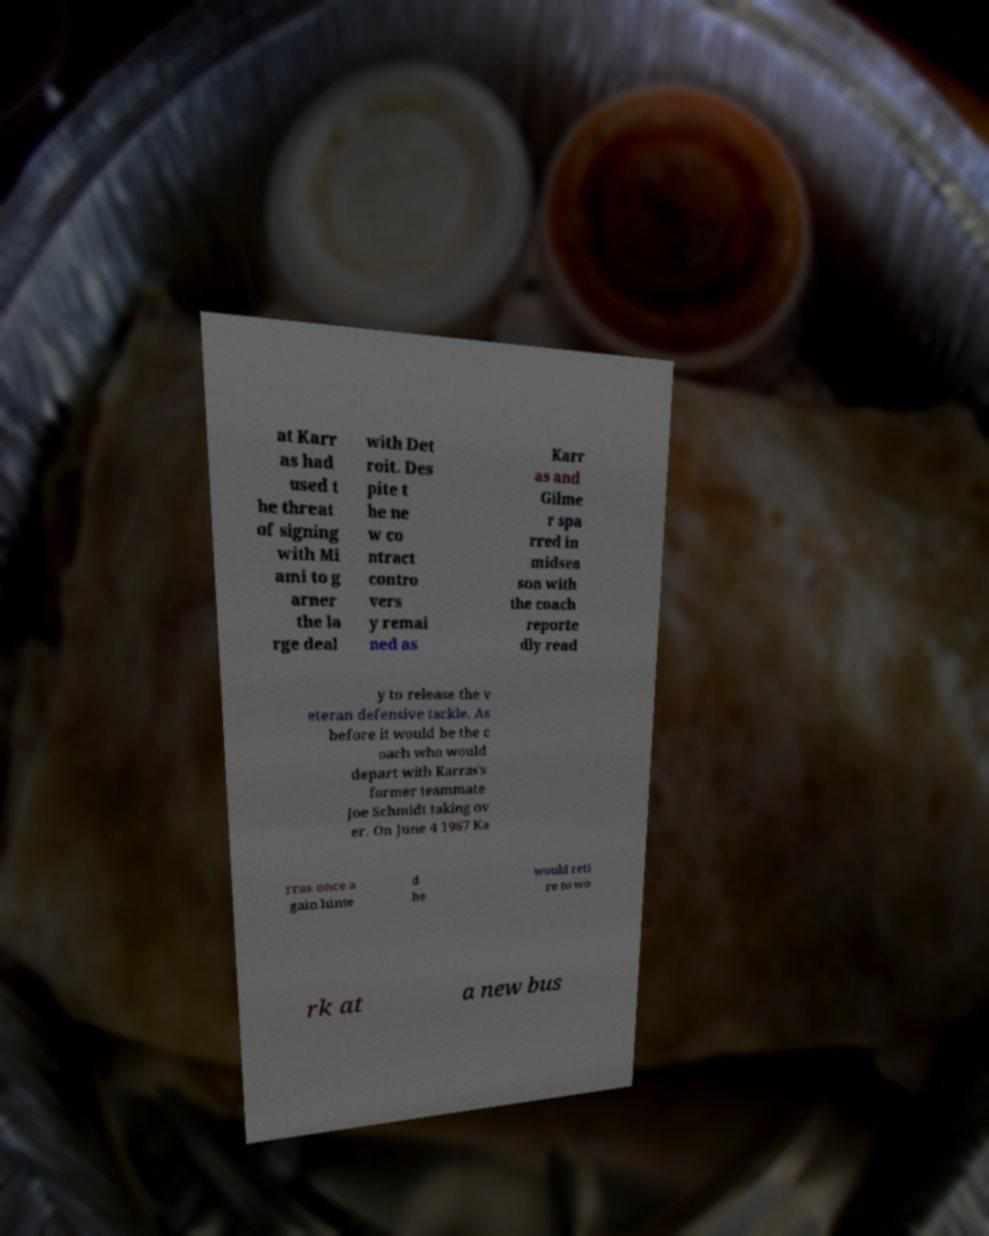There's text embedded in this image that I need extracted. Can you transcribe it verbatim? at Karr as had used t he threat of signing with Mi ami to g arner the la rge deal with Det roit. Des pite t he ne w co ntract contro vers y remai ned as Karr as and Gilme r spa rred in midsea son with the coach reporte dly read y to release the v eteran defensive tackle. As before it would be the c oach who would depart with Karras's former teammate Joe Schmidt taking ov er. On June 4 1967 Ka rras once a gain hinte d he would reti re to wo rk at a new bus 